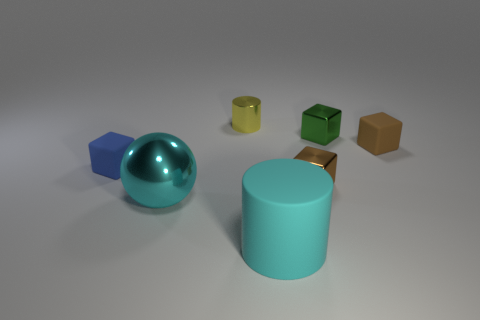Is the number of blocks on the right side of the yellow metal thing greater than the number of small gray spheres? Yes, there are more blocks on the right side of the yellow metal thing compared to the number of small gray spheres. Specifically, there are three blocks positioned to the right of the yellow object, while there are only two small gray spheres present in the image. 